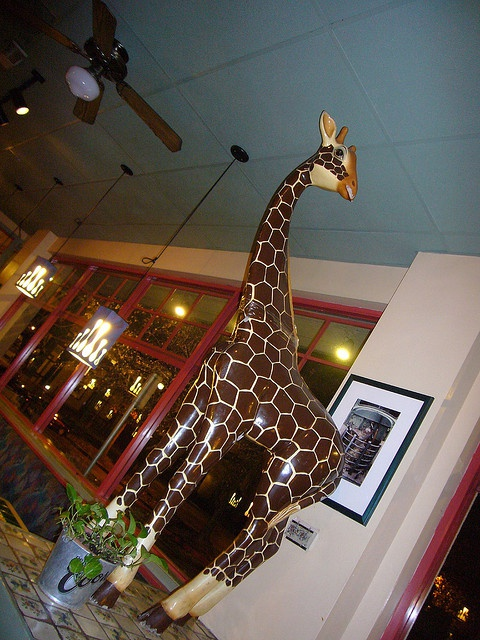Describe the objects in this image and their specific colors. I can see a potted plant in black, gray, and darkgreen tones in this image. 